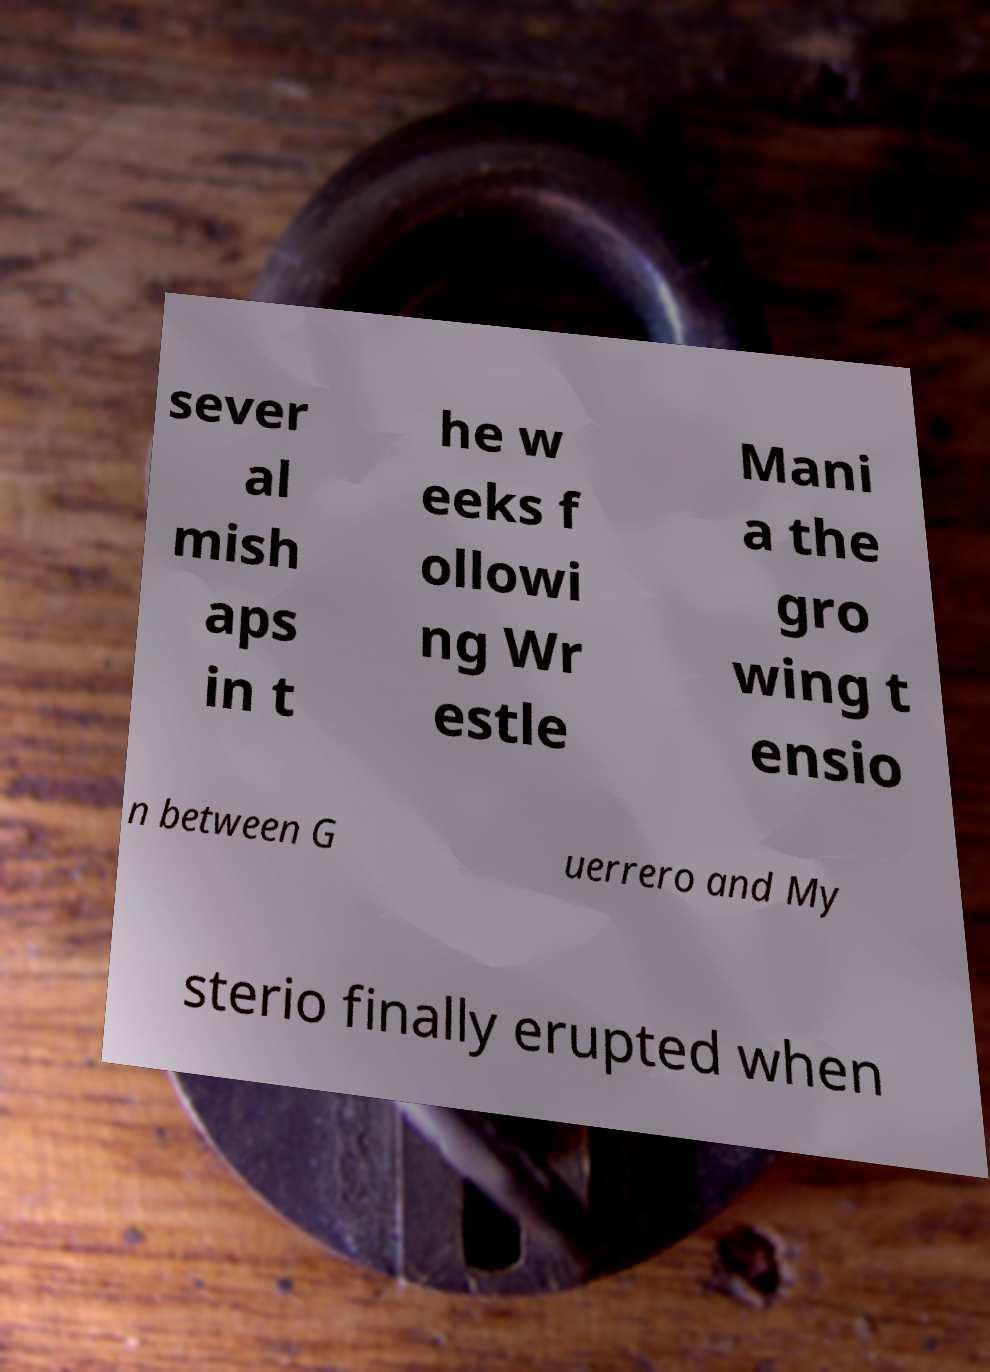Could you extract and type out the text from this image? sever al mish aps in t he w eeks f ollowi ng Wr estle Mani a the gro wing t ensio n between G uerrero and My sterio finally erupted when 